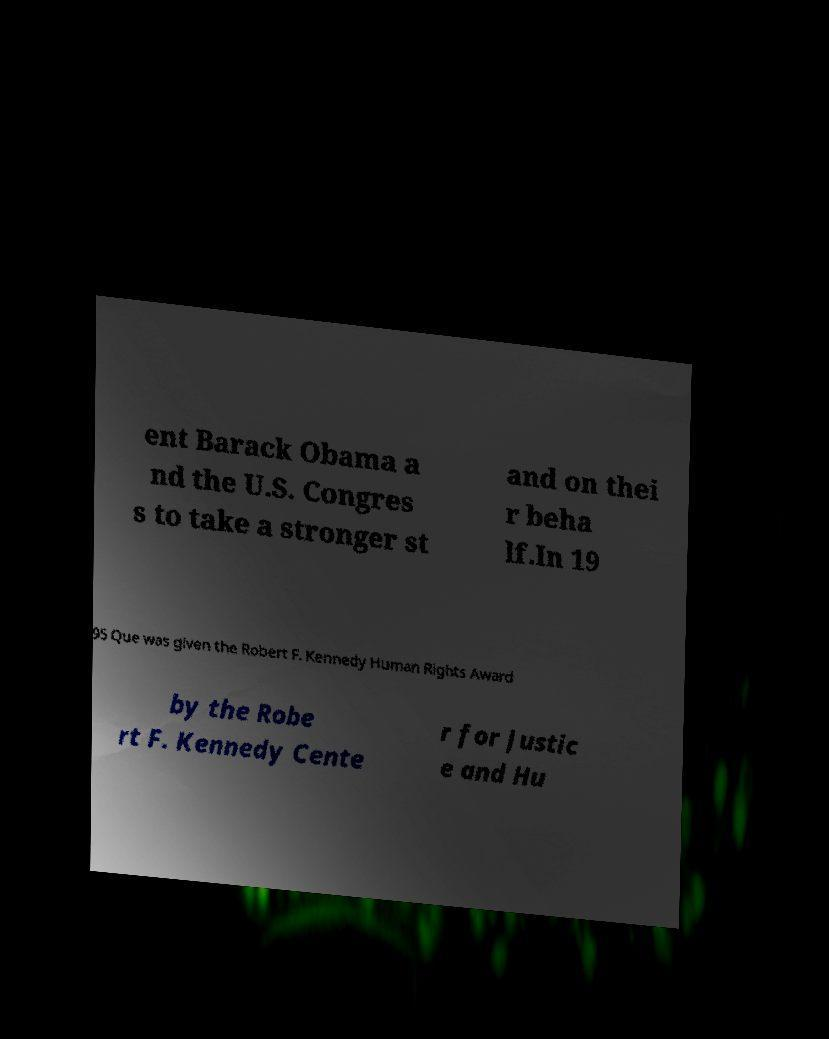For documentation purposes, I need the text within this image transcribed. Could you provide that? ent Barack Obama a nd the U.S. Congres s to take a stronger st and on thei r beha lf.In 19 95 Que was given the Robert F. Kennedy Human Rights Award by the Robe rt F. Kennedy Cente r for Justic e and Hu 